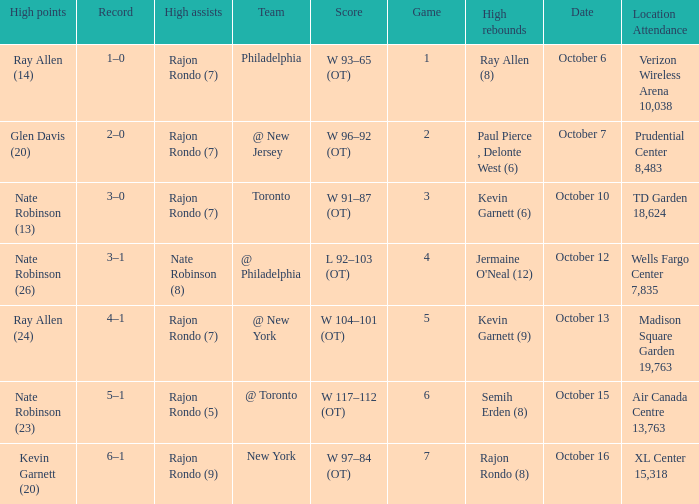Can you give me this table as a dict? {'header': ['High points', 'Record', 'High assists', 'Team', 'Score', 'Game', 'High rebounds', 'Date', 'Location Attendance'], 'rows': [['Ray Allen (14)', '1–0', 'Rajon Rondo (7)', 'Philadelphia', 'W 93–65 (OT)', '1', 'Ray Allen (8)', 'October 6', 'Verizon Wireless Arena 10,038'], ['Glen Davis (20)', '2–0', 'Rajon Rondo (7)', '@ New Jersey', 'W 96–92 (OT)', '2', 'Paul Pierce , Delonte West (6)', 'October 7', 'Prudential Center 8,483'], ['Nate Robinson (13)', '3–0', 'Rajon Rondo (7)', 'Toronto', 'W 91–87 (OT)', '3', 'Kevin Garnett (6)', 'October 10', 'TD Garden 18,624'], ['Nate Robinson (26)', '3–1', 'Nate Robinson (8)', '@ Philadelphia', 'L 92–103 (OT)', '4', "Jermaine O'Neal (12)", 'October 12', 'Wells Fargo Center 7,835'], ['Ray Allen (24)', '4–1', 'Rajon Rondo (7)', '@ New York', 'W 104–101 (OT)', '5', 'Kevin Garnett (9)', 'October 13', 'Madison Square Garden 19,763'], ['Nate Robinson (23)', '5–1', 'Rajon Rondo (5)', '@ Toronto', 'W 117–112 (OT)', '6', 'Semih Erden (8)', 'October 15', 'Air Canada Centre 13,763'], ['Kevin Garnett (20)', '6–1', 'Rajon Rondo (9)', 'New York', 'W 97–84 (OT)', '7', 'Rajon Rondo (8)', 'October 16', 'XL Center 15,318']]} Who had the most assists and how many did they have on October 7?  Rajon Rondo (7). 